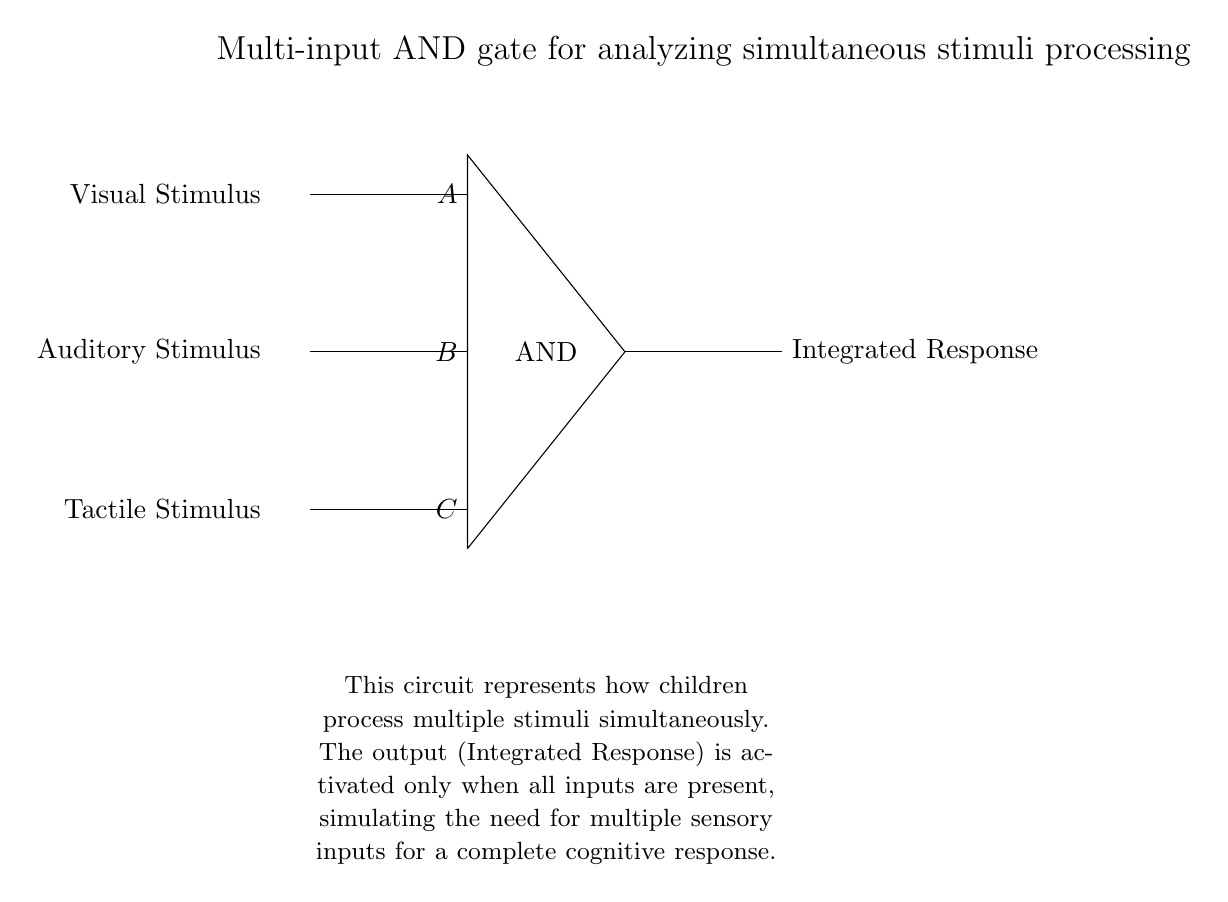What is the output of the AND gate when all inputs are present? The output of an AND gate is high (1 or true) only when all of its inputs are high (1 or true). In this case, when the visual, auditory, and tactile stimuli are all present, the output (Integrated Response) will be activated.
Answer: Integrated Response How many inputs does this AND gate have? The diagram clearly shows three lines entering the AND gate, indicating three distinct inputs: Visual Stimulus, Auditory Stimulus, and Tactile Stimulus.
Answer: Three What stimuli are represented as inputs to the circuit? The diagram labels three inputs - the first input is labeled "Visual Stimulus," the second is "Auditory Stimulus," and the third is "Tactile Stimulus," all of which correspond to different types of sensory input.
Answer: Visual Stimulus, Auditory Stimulus, Tactile Stimulus What condition is needed for the AND gate to produce an output? An AND gate produces an output when all inputs are high (or true). In this case, all three stimuli (Visual, Auditory, and Tactile) must be present for the Integrated Response to activate.
Answer: All inputs need to be high What is the significance of the 'Integrated Response' output? The Integrated Response represents the cognitive output of the system when all sensory inputs are processed together, simulating how children with learning disabilities might need to integrate multiple stimuli for a complete understanding or reaction.
Answer: Simultaneous processing of stimuli 